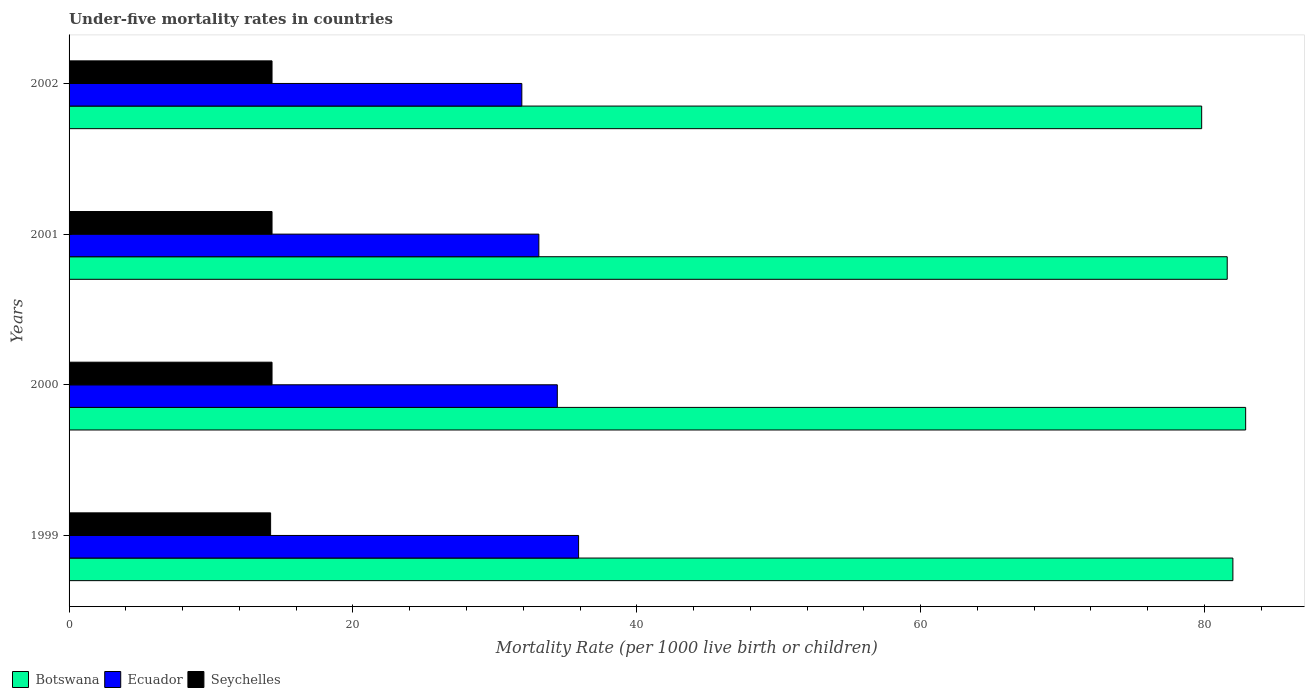How many different coloured bars are there?
Offer a very short reply. 3. How many groups of bars are there?
Offer a terse response. 4. Are the number of bars per tick equal to the number of legend labels?
Offer a terse response. Yes. In how many cases, is the number of bars for a given year not equal to the number of legend labels?
Make the answer very short. 0. What is the under-five mortality rate in Ecuador in 2000?
Ensure brevity in your answer.  34.4. Across all years, what is the maximum under-five mortality rate in Botswana?
Offer a very short reply. 82.9. Across all years, what is the minimum under-five mortality rate in Seychelles?
Keep it short and to the point. 14.2. In which year was the under-five mortality rate in Ecuador minimum?
Your response must be concise. 2002. What is the total under-five mortality rate in Seychelles in the graph?
Your response must be concise. 57.1. What is the difference between the under-five mortality rate in Seychelles in 2000 and that in 2001?
Offer a very short reply. 0. What is the difference between the under-five mortality rate in Ecuador in 2000 and the under-five mortality rate in Seychelles in 1999?
Your response must be concise. 20.2. What is the average under-five mortality rate in Botswana per year?
Your answer should be compact. 81.58. In the year 1999, what is the difference between the under-five mortality rate in Ecuador and under-five mortality rate in Seychelles?
Keep it short and to the point. 21.7. In how many years, is the under-five mortality rate in Seychelles greater than 40 ?
Your answer should be very brief. 0. What is the ratio of the under-five mortality rate in Seychelles in 1999 to that in 2001?
Provide a short and direct response. 0.99. Is the under-five mortality rate in Ecuador in 2001 less than that in 2002?
Ensure brevity in your answer.  No. What is the difference between the highest and the second highest under-five mortality rate in Ecuador?
Offer a terse response. 1.5. What is the difference between the highest and the lowest under-five mortality rate in Botswana?
Keep it short and to the point. 3.1. In how many years, is the under-five mortality rate in Botswana greater than the average under-five mortality rate in Botswana taken over all years?
Your answer should be very brief. 3. What does the 2nd bar from the top in 2001 represents?
Your answer should be compact. Ecuador. What does the 1st bar from the bottom in 2000 represents?
Your answer should be very brief. Botswana. What is the difference between two consecutive major ticks on the X-axis?
Provide a short and direct response. 20. Are the values on the major ticks of X-axis written in scientific E-notation?
Provide a succinct answer. No. How many legend labels are there?
Your response must be concise. 3. How are the legend labels stacked?
Provide a succinct answer. Horizontal. What is the title of the graph?
Your answer should be compact. Under-five mortality rates in countries. Does "Egypt, Arab Rep." appear as one of the legend labels in the graph?
Make the answer very short. No. What is the label or title of the X-axis?
Offer a terse response. Mortality Rate (per 1000 live birth or children). What is the Mortality Rate (per 1000 live birth or children) in Botswana in 1999?
Your answer should be compact. 82. What is the Mortality Rate (per 1000 live birth or children) in Ecuador in 1999?
Your response must be concise. 35.9. What is the Mortality Rate (per 1000 live birth or children) of Seychelles in 1999?
Provide a succinct answer. 14.2. What is the Mortality Rate (per 1000 live birth or children) of Botswana in 2000?
Offer a terse response. 82.9. What is the Mortality Rate (per 1000 live birth or children) of Ecuador in 2000?
Your response must be concise. 34.4. What is the Mortality Rate (per 1000 live birth or children) in Botswana in 2001?
Give a very brief answer. 81.6. What is the Mortality Rate (per 1000 live birth or children) of Ecuador in 2001?
Ensure brevity in your answer.  33.1. What is the Mortality Rate (per 1000 live birth or children) in Seychelles in 2001?
Provide a succinct answer. 14.3. What is the Mortality Rate (per 1000 live birth or children) in Botswana in 2002?
Your answer should be compact. 79.8. What is the Mortality Rate (per 1000 live birth or children) in Ecuador in 2002?
Ensure brevity in your answer.  31.9. What is the Mortality Rate (per 1000 live birth or children) in Seychelles in 2002?
Your response must be concise. 14.3. Across all years, what is the maximum Mortality Rate (per 1000 live birth or children) in Botswana?
Provide a short and direct response. 82.9. Across all years, what is the maximum Mortality Rate (per 1000 live birth or children) of Ecuador?
Ensure brevity in your answer.  35.9. Across all years, what is the maximum Mortality Rate (per 1000 live birth or children) of Seychelles?
Your response must be concise. 14.3. Across all years, what is the minimum Mortality Rate (per 1000 live birth or children) in Botswana?
Provide a short and direct response. 79.8. Across all years, what is the minimum Mortality Rate (per 1000 live birth or children) of Ecuador?
Offer a terse response. 31.9. Across all years, what is the minimum Mortality Rate (per 1000 live birth or children) in Seychelles?
Offer a very short reply. 14.2. What is the total Mortality Rate (per 1000 live birth or children) in Botswana in the graph?
Your answer should be compact. 326.3. What is the total Mortality Rate (per 1000 live birth or children) in Ecuador in the graph?
Offer a terse response. 135.3. What is the total Mortality Rate (per 1000 live birth or children) of Seychelles in the graph?
Ensure brevity in your answer.  57.1. What is the difference between the Mortality Rate (per 1000 live birth or children) of Botswana in 1999 and that in 2000?
Provide a short and direct response. -0.9. What is the difference between the Mortality Rate (per 1000 live birth or children) in Seychelles in 1999 and that in 2000?
Offer a very short reply. -0.1. What is the difference between the Mortality Rate (per 1000 live birth or children) in Botswana in 1999 and that in 2001?
Make the answer very short. 0.4. What is the difference between the Mortality Rate (per 1000 live birth or children) of Ecuador in 1999 and that in 2001?
Offer a very short reply. 2.8. What is the difference between the Mortality Rate (per 1000 live birth or children) of Seychelles in 1999 and that in 2001?
Give a very brief answer. -0.1. What is the difference between the Mortality Rate (per 1000 live birth or children) in Ecuador in 1999 and that in 2002?
Give a very brief answer. 4. What is the difference between the Mortality Rate (per 1000 live birth or children) in Botswana in 2000 and that in 2001?
Provide a succinct answer. 1.3. What is the difference between the Mortality Rate (per 1000 live birth or children) of Ecuador in 2000 and that in 2001?
Ensure brevity in your answer.  1.3. What is the difference between the Mortality Rate (per 1000 live birth or children) in Botswana in 2000 and that in 2002?
Your answer should be compact. 3.1. What is the difference between the Mortality Rate (per 1000 live birth or children) of Ecuador in 2000 and that in 2002?
Your answer should be very brief. 2.5. What is the difference between the Mortality Rate (per 1000 live birth or children) in Botswana in 2001 and that in 2002?
Ensure brevity in your answer.  1.8. What is the difference between the Mortality Rate (per 1000 live birth or children) in Seychelles in 2001 and that in 2002?
Make the answer very short. 0. What is the difference between the Mortality Rate (per 1000 live birth or children) of Botswana in 1999 and the Mortality Rate (per 1000 live birth or children) of Ecuador in 2000?
Offer a very short reply. 47.6. What is the difference between the Mortality Rate (per 1000 live birth or children) of Botswana in 1999 and the Mortality Rate (per 1000 live birth or children) of Seychelles in 2000?
Offer a terse response. 67.7. What is the difference between the Mortality Rate (per 1000 live birth or children) in Ecuador in 1999 and the Mortality Rate (per 1000 live birth or children) in Seychelles in 2000?
Offer a terse response. 21.6. What is the difference between the Mortality Rate (per 1000 live birth or children) in Botswana in 1999 and the Mortality Rate (per 1000 live birth or children) in Ecuador in 2001?
Offer a terse response. 48.9. What is the difference between the Mortality Rate (per 1000 live birth or children) of Botswana in 1999 and the Mortality Rate (per 1000 live birth or children) of Seychelles in 2001?
Provide a short and direct response. 67.7. What is the difference between the Mortality Rate (per 1000 live birth or children) of Ecuador in 1999 and the Mortality Rate (per 1000 live birth or children) of Seychelles in 2001?
Offer a terse response. 21.6. What is the difference between the Mortality Rate (per 1000 live birth or children) of Botswana in 1999 and the Mortality Rate (per 1000 live birth or children) of Ecuador in 2002?
Provide a short and direct response. 50.1. What is the difference between the Mortality Rate (per 1000 live birth or children) of Botswana in 1999 and the Mortality Rate (per 1000 live birth or children) of Seychelles in 2002?
Ensure brevity in your answer.  67.7. What is the difference between the Mortality Rate (per 1000 live birth or children) of Ecuador in 1999 and the Mortality Rate (per 1000 live birth or children) of Seychelles in 2002?
Provide a short and direct response. 21.6. What is the difference between the Mortality Rate (per 1000 live birth or children) in Botswana in 2000 and the Mortality Rate (per 1000 live birth or children) in Ecuador in 2001?
Offer a very short reply. 49.8. What is the difference between the Mortality Rate (per 1000 live birth or children) of Botswana in 2000 and the Mortality Rate (per 1000 live birth or children) of Seychelles in 2001?
Keep it short and to the point. 68.6. What is the difference between the Mortality Rate (per 1000 live birth or children) in Ecuador in 2000 and the Mortality Rate (per 1000 live birth or children) in Seychelles in 2001?
Your answer should be very brief. 20.1. What is the difference between the Mortality Rate (per 1000 live birth or children) of Botswana in 2000 and the Mortality Rate (per 1000 live birth or children) of Ecuador in 2002?
Keep it short and to the point. 51. What is the difference between the Mortality Rate (per 1000 live birth or children) of Botswana in 2000 and the Mortality Rate (per 1000 live birth or children) of Seychelles in 2002?
Provide a short and direct response. 68.6. What is the difference between the Mortality Rate (per 1000 live birth or children) in Ecuador in 2000 and the Mortality Rate (per 1000 live birth or children) in Seychelles in 2002?
Offer a very short reply. 20.1. What is the difference between the Mortality Rate (per 1000 live birth or children) of Botswana in 2001 and the Mortality Rate (per 1000 live birth or children) of Ecuador in 2002?
Keep it short and to the point. 49.7. What is the difference between the Mortality Rate (per 1000 live birth or children) in Botswana in 2001 and the Mortality Rate (per 1000 live birth or children) in Seychelles in 2002?
Provide a succinct answer. 67.3. What is the average Mortality Rate (per 1000 live birth or children) of Botswana per year?
Offer a very short reply. 81.58. What is the average Mortality Rate (per 1000 live birth or children) of Ecuador per year?
Keep it short and to the point. 33.83. What is the average Mortality Rate (per 1000 live birth or children) in Seychelles per year?
Offer a very short reply. 14.28. In the year 1999, what is the difference between the Mortality Rate (per 1000 live birth or children) of Botswana and Mortality Rate (per 1000 live birth or children) of Ecuador?
Provide a short and direct response. 46.1. In the year 1999, what is the difference between the Mortality Rate (per 1000 live birth or children) in Botswana and Mortality Rate (per 1000 live birth or children) in Seychelles?
Make the answer very short. 67.8. In the year 1999, what is the difference between the Mortality Rate (per 1000 live birth or children) of Ecuador and Mortality Rate (per 1000 live birth or children) of Seychelles?
Offer a terse response. 21.7. In the year 2000, what is the difference between the Mortality Rate (per 1000 live birth or children) of Botswana and Mortality Rate (per 1000 live birth or children) of Ecuador?
Provide a short and direct response. 48.5. In the year 2000, what is the difference between the Mortality Rate (per 1000 live birth or children) of Botswana and Mortality Rate (per 1000 live birth or children) of Seychelles?
Your answer should be compact. 68.6. In the year 2000, what is the difference between the Mortality Rate (per 1000 live birth or children) in Ecuador and Mortality Rate (per 1000 live birth or children) in Seychelles?
Make the answer very short. 20.1. In the year 2001, what is the difference between the Mortality Rate (per 1000 live birth or children) in Botswana and Mortality Rate (per 1000 live birth or children) in Ecuador?
Offer a terse response. 48.5. In the year 2001, what is the difference between the Mortality Rate (per 1000 live birth or children) of Botswana and Mortality Rate (per 1000 live birth or children) of Seychelles?
Your answer should be very brief. 67.3. In the year 2002, what is the difference between the Mortality Rate (per 1000 live birth or children) of Botswana and Mortality Rate (per 1000 live birth or children) of Ecuador?
Your response must be concise. 47.9. In the year 2002, what is the difference between the Mortality Rate (per 1000 live birth or children) of Botswana and Mortality Rate (per 1000 live birth or children) of Seychelles?
Provide a short and direct response. 65.5. What is the ratio of the Mortality Rate (per 1000 live birth or children) in Botswana in 1999 to that in 2000?
Offer a terse response. 0.99. What is the ratio of the Mortality Rate (per 1000 live birth or children) of Ecuador in 1999 to that in 2000?
Keep it short and to the point. 1.04. What is the ratio of the Mortality Rate (per 1000 live birth or children) in Seychelles in 1999 to that in 2000?
Ensure brevity in your answer.  0.99. What is the ratio of the Mortality Rate (per 1000 live birth or children) of Botswana in 1999 to that in 2001?
Keep it short and to the point. 1. What is the ratio of the Mortality Rate (per 1000 live birth or children) in Ecuador in 1999 to that in 2001?
Provide a short and direct response. 1.08. What is the ratio of the Mortality Rate (per 1000 live birth or children) in Seychelles in 1999 to that in 2001?
Offer a very short reply. 0.99. What is the ratio of the Mortality Rate (per 1000 live birth or children) of Botswana in 1999 to that in 2002?
Give a very brief answer. 1.03. What is the ratio of the Mortality Rate (per 1000 live birth or children) in Ecuador in 1999 to that in 2002?
Your answer should be very brief. 1.13. What is the ratio of the Mortality Rate (per 1000 live birth or children) of Botswana in 2000 to that in 2001?
Provide a short and direct response. 1.02. What is the ratio of the Mortality Rate (per 1000 live birth or children) of Ecuador in 2000 to that in 2001?
Your response must be concise. 1.04. What is the ratio of the Mortality Rate (per 1000 live birth or children) in Seychelles in 2000 to that in 2001?
Ensure brevity in your answer.  1. What is the ratio of the Mortality Rate (per 1000 live birth or children) of Botswana in 2000 to that in 2002?
Give a very brief answer. 1.04. What is the ratio of the Mortality Rate (per 1000 live birth or children) in Ecuador in 2000 to that in 2002?
Provide a succinct answer. 1.08. What is the ratio of the Mortality Rate (per 1000 live birth or children) of Botswana in 2001 to that in 2002?
Offer a terse response. 1.02. What is the ratio of the Mortality Rate (per 1000 live birth or children) of Ecuador in 2001 to that in 2002?
Your answer should be compact. 1.04. What is the difference between the highest and the second highest Mortality Rate (per 1000 live birth or children) of Ecuador?
Offer a very short reply. 1.5. What is the difference between the highest and the lowest Mortality Rate (per 1000 live birth or children) in Ecuador?
Your answer should be compact. 4. 